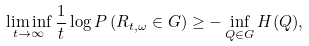Convert formula to latex. <formula><loc_0><loc_0><loc_500><loc_500>\liminf _ { t \rightarrow \infty } \frac { 1 } { t } \log P \left ( R _ { t , \omega } \in G \right ) \geq - \inf _ { Q \in G } H ( Q ) ,</formula> 